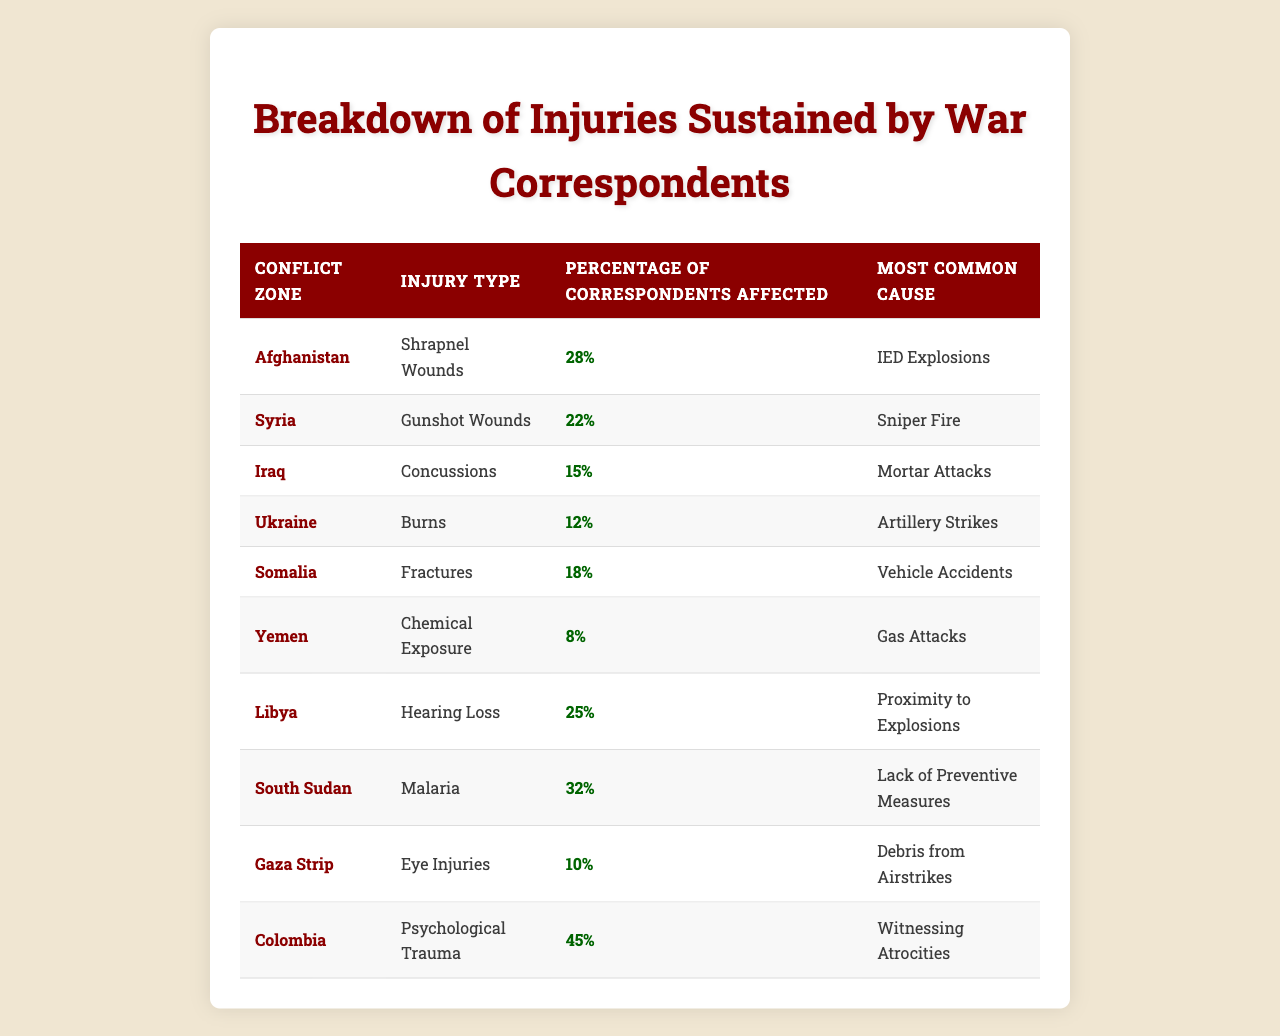What is the injury type most reported in Colombia? The table indicates that the injury type most reported in Colombia is "Psychological Trauma."
Answer: Psychological Trauma Which conflict zone has the highest percentage of correspondents affected by injuries? According to the table, Colombia has the highest percentage of correspondents affected by injuries at 45%.
Answer: 45% What is the most common cause of fractures in Somalia? The table shows that the most common cause of fractures in Somalia is "Vehicle Accidents."
Answer: Vehicle Accidents How many different types of injuries are reported for Afghanistan? The table specifies that only one injury type, "Shrapnel Wounds," is reported for Afghanistan.
Answer: 1 Which conflict zone and injury type combination has the lowest percentage of correspondents affected? The lowest percentage of correspondents affected is in Yemen with "Chemical Exposure" at 8%.
Answer: Yemen, Chemical Exposure If we combine the percentage of correspondents affected by "Burns" in Ukraine and "Eye Injuries" in the Gaza Strip, what is the total percentage? The percentage for "Burns" in Ukraine is 12% and for "Eye Injuries" in the Gaza Strip is 10%. Adding these gives 12% + 10% = 22%.
Answer: 22% True or False: More correspondents are affected by malaria in South Sudan than by gunshot wounds in Syria. The table shows 32% for malaria in South Sudan and 22% for gunshot wounds in Syria. Since 32% is greater than 22%, the statement is true.
Answer: True Which types of injuries are associated with conflict zones that have percentages above 20%? The injuries associated with percentages above 20% are "Shrapnel Wounds" in Afghanistan (28%), "Gunshot Wounds" in Syria (22%), "Hearing Loss" in Libya (25%), "Malaria" in South Sudan (32%), and "Psychological Trauma" in Colombia (45%).
Answer: 5 types If we were to rank the conflict zones by the percentage of correspondents affected from highest to lowest, what would be the top three? The table lists the top three zones as Colombia (45%), South Sudan (32%), and Afghanistan (28%).
Answer: Colombia, South Sudan, Afghanistan What percentage of war correspondents in Ukraine are affected by burns? The table states that 12% of war correspondents in Ukraine are affected by burns.
Answer: 12% 